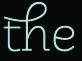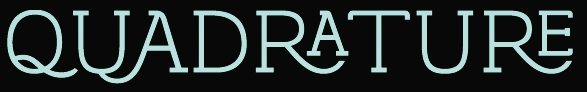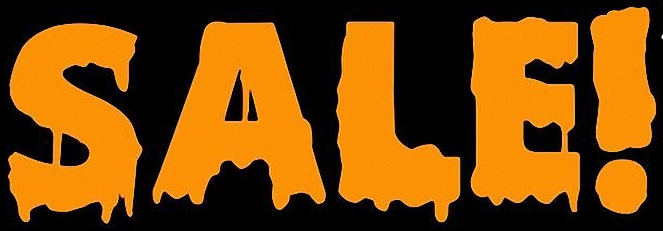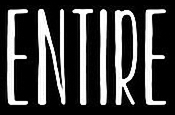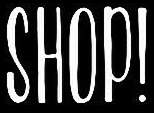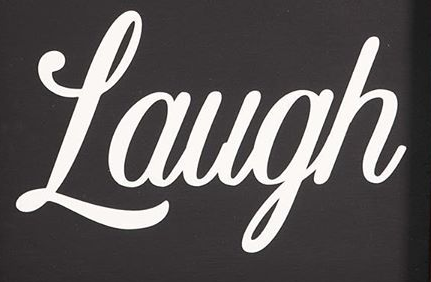Transcribe the words shown in these images in order, separated by a semicolon. the; QUADRATURE; SALE!; ENTIRE; SHOP!; Laugh 